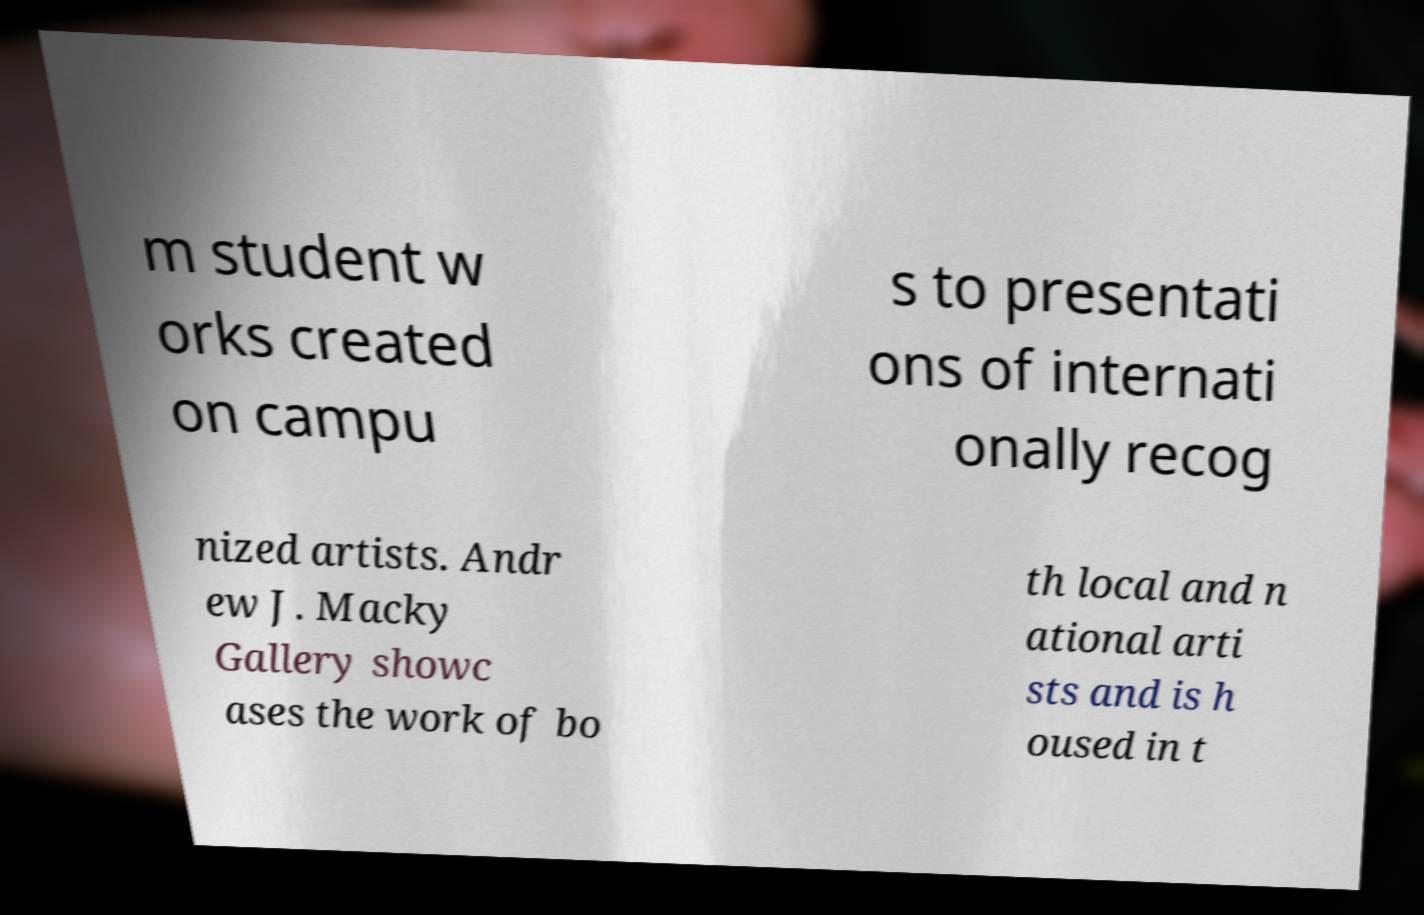Can you accurately transcribe the text from the provided image for me? m student w orks created on campu s to presentati ons of internati onally recog nized artists. Andr ew J. Macky Gallery showc ases the work of bo th local and n ational arti sts and is h oused in t 